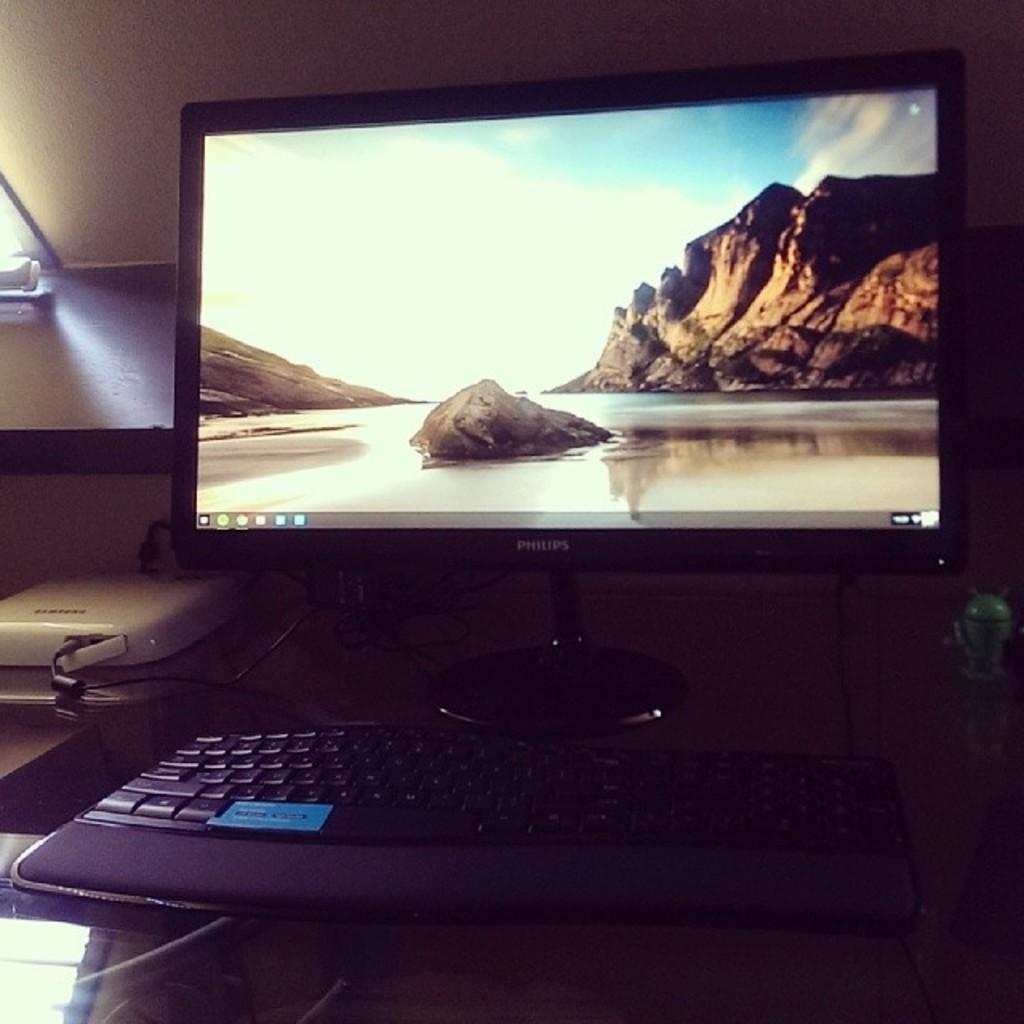What is the brand of the monitor?
Your response must be concise. Philips. 